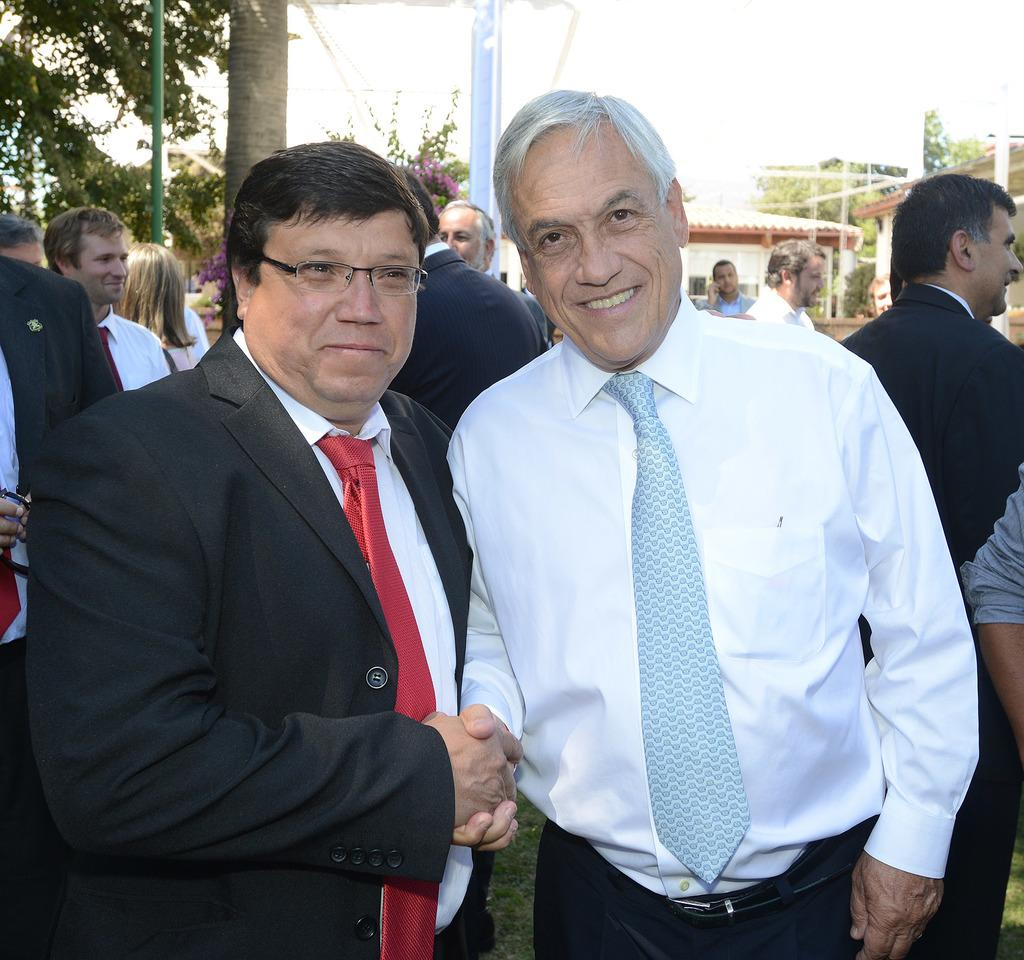What are the two people in the image doing? The two people in the image are standing and shaking hands. Can you describe the attire of the person on the left? The person on the left is wearing a suit. What can be seen in the background of the image? There are other people, poles, trees, and buildings visible in the background. How many islands can be seen in the image? There are no islands visible in the image. What type of cracker is being used to prop open the drain in the image? There is no cracker or drain present in the image. 